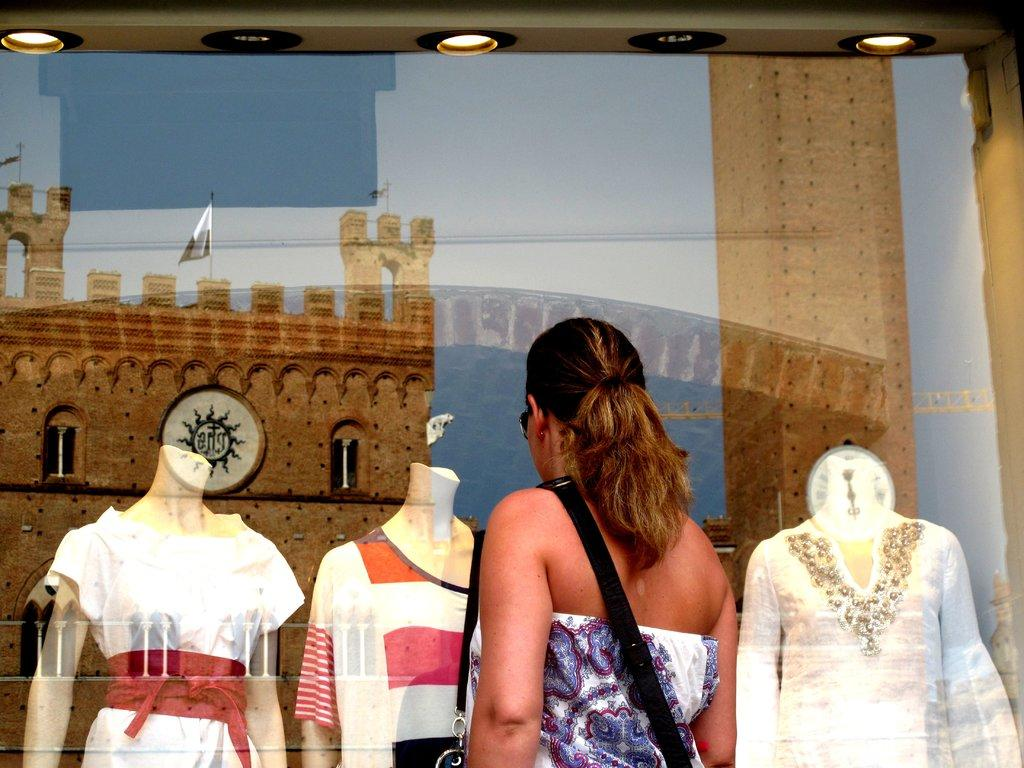What is the main subject in the image? There is a person standing in the image. What else can be seen in the image besides the person? There are mannequins with dresses, lights, a reflection of a fort, and flags with poles in the image. What is the condition of the sky in the image? The sky is visible in the image. Can you see any cobwebs in the image? There is no mention of cobwebs in the image, so it cannot be determined if any are present. What type of business is being conducted in the image? There is no indication of a business being conducted in the image. 